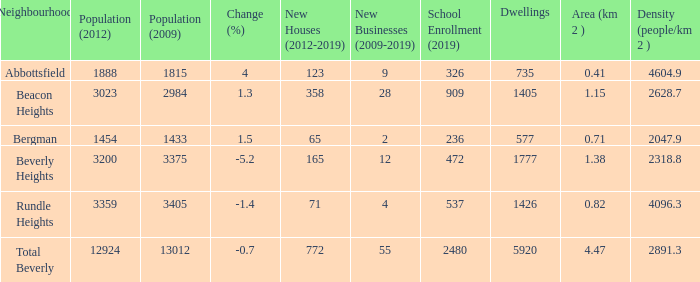38km and with more than 12924 residents? 0.0. Can you parse all the data within this table? {'header': ['Neighbourhood', 'Population (2012)', 'Population (2009)', 'Change (%)', 'New Houses (2012-2019)', 'New Businesses (2009-2019)', 'School Enrollment (2019)', 'Dwellings', 'Area (km 2 )', 'Density (people/km 2 )'], 'rows': [['Abbottsfield', '1888', '1815', '4', '123', '9', '326', '735', '0.41', '4604.9'], ['Beacon Heights', '3023', '2984', '1.3', '358', '28', '909', '1405', '1.15', '2628.7'], ['Bergman', '1454', '1433', '1.5', '65', '2', '236', '577', '0.71', '2047.9'], ['Beverly Heights', '3200', '3375', '-5.2', '165', '12', '472', '1777', '1.38', '2318.8'], ['Rundle Heights', '3359', '3405', '-1.4', '71', '4', '537', '1426', '0.82', '4096.3'], ['Total Beverly', '12924', '13012', '-0.7', '772', '55', '2480', '5920', '4.47', '2891.3']]} 